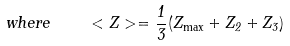<formula> <loc_0><loc_0><loc_500><loc_500>w h e r e \quad < Z > = \frac { 1 } { 3 } ( Z _ { \max } + Z _ { 2 } + Z _ { 3 } )</formula> 